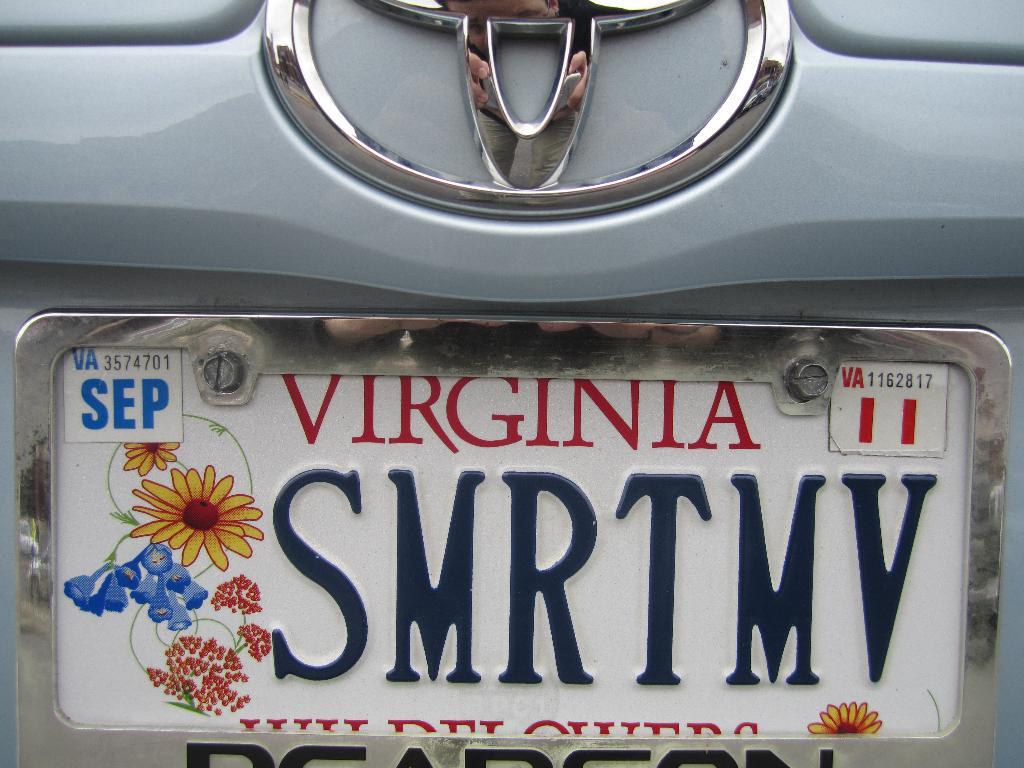What state is the plate from?
Ensure brevity in your answer.  Virginia. 